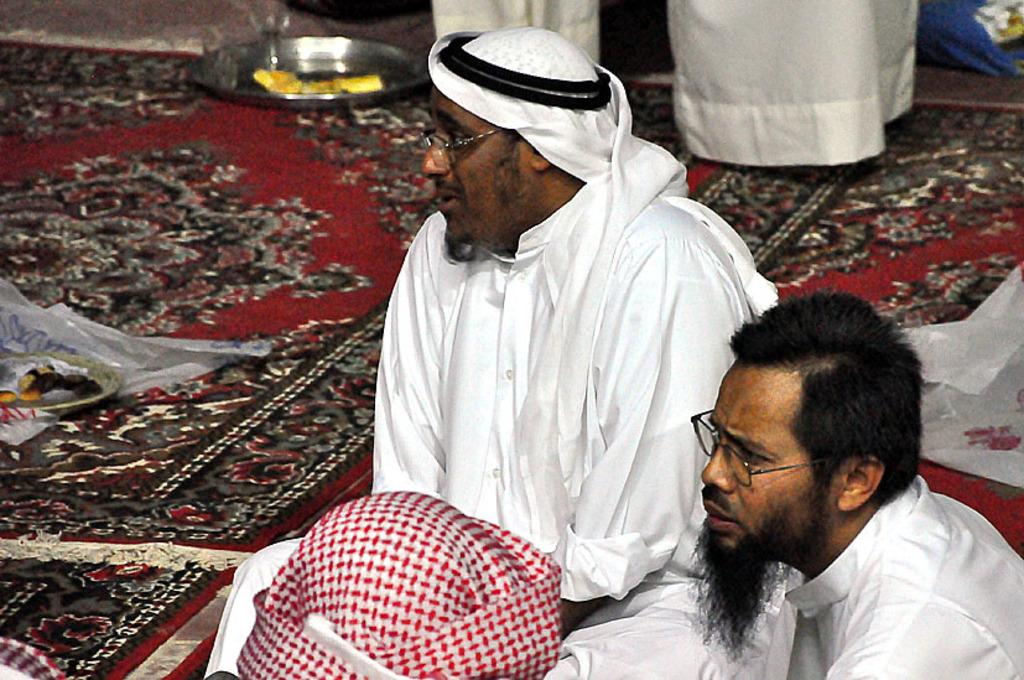Who or what can be seen in the image? There are people in the image. What is the representation of in the image? There is a representation of Mars in the image. What objects are visible in the background of the image? There is a plate and a glass in the background of the image. What type of pies are being served on the plate in the image? There is no plate with pies present in the image; the plate is empty. Can you see any coal in the image? There is no coal present in the image. Is there a tiger visible in the image? There is no tiger present in the image. 